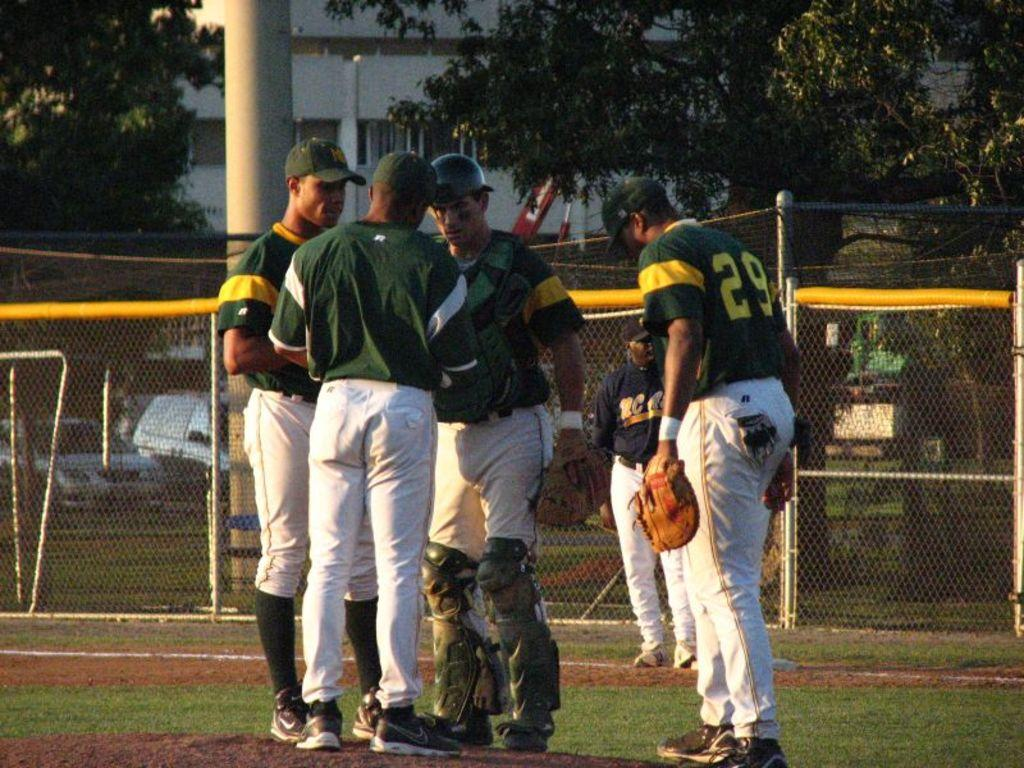<image>
Write a terse but informative summary of the picture. Baseball players wearing green and yellow jerseys with white pants huddle around talking among them player 29. 